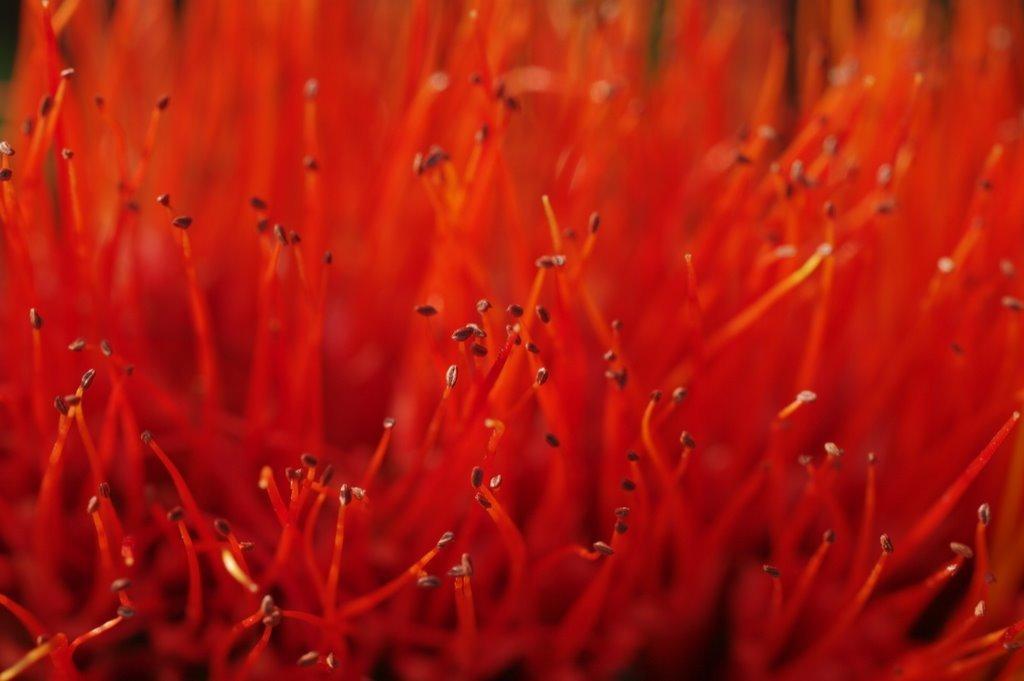How would you summarize this image in a sentence or two? In the image we can see the pollen, red in color. 